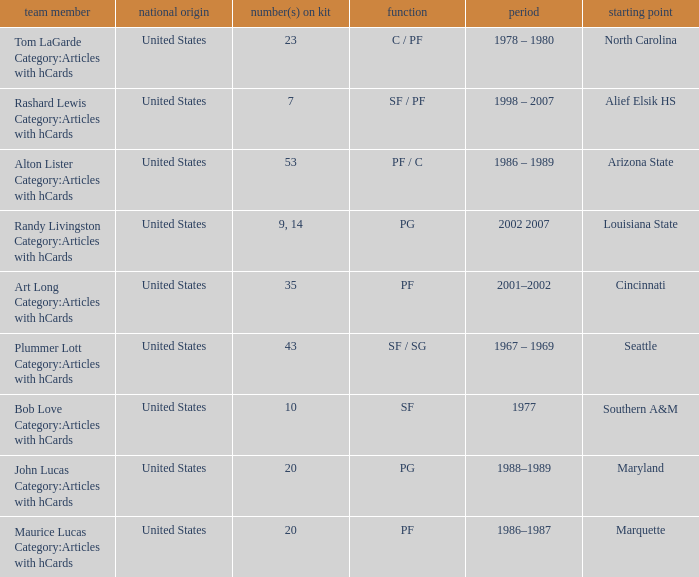Tom Lagarde Category:Articles with hCards used what Jersey Number(s)? 23.0. 